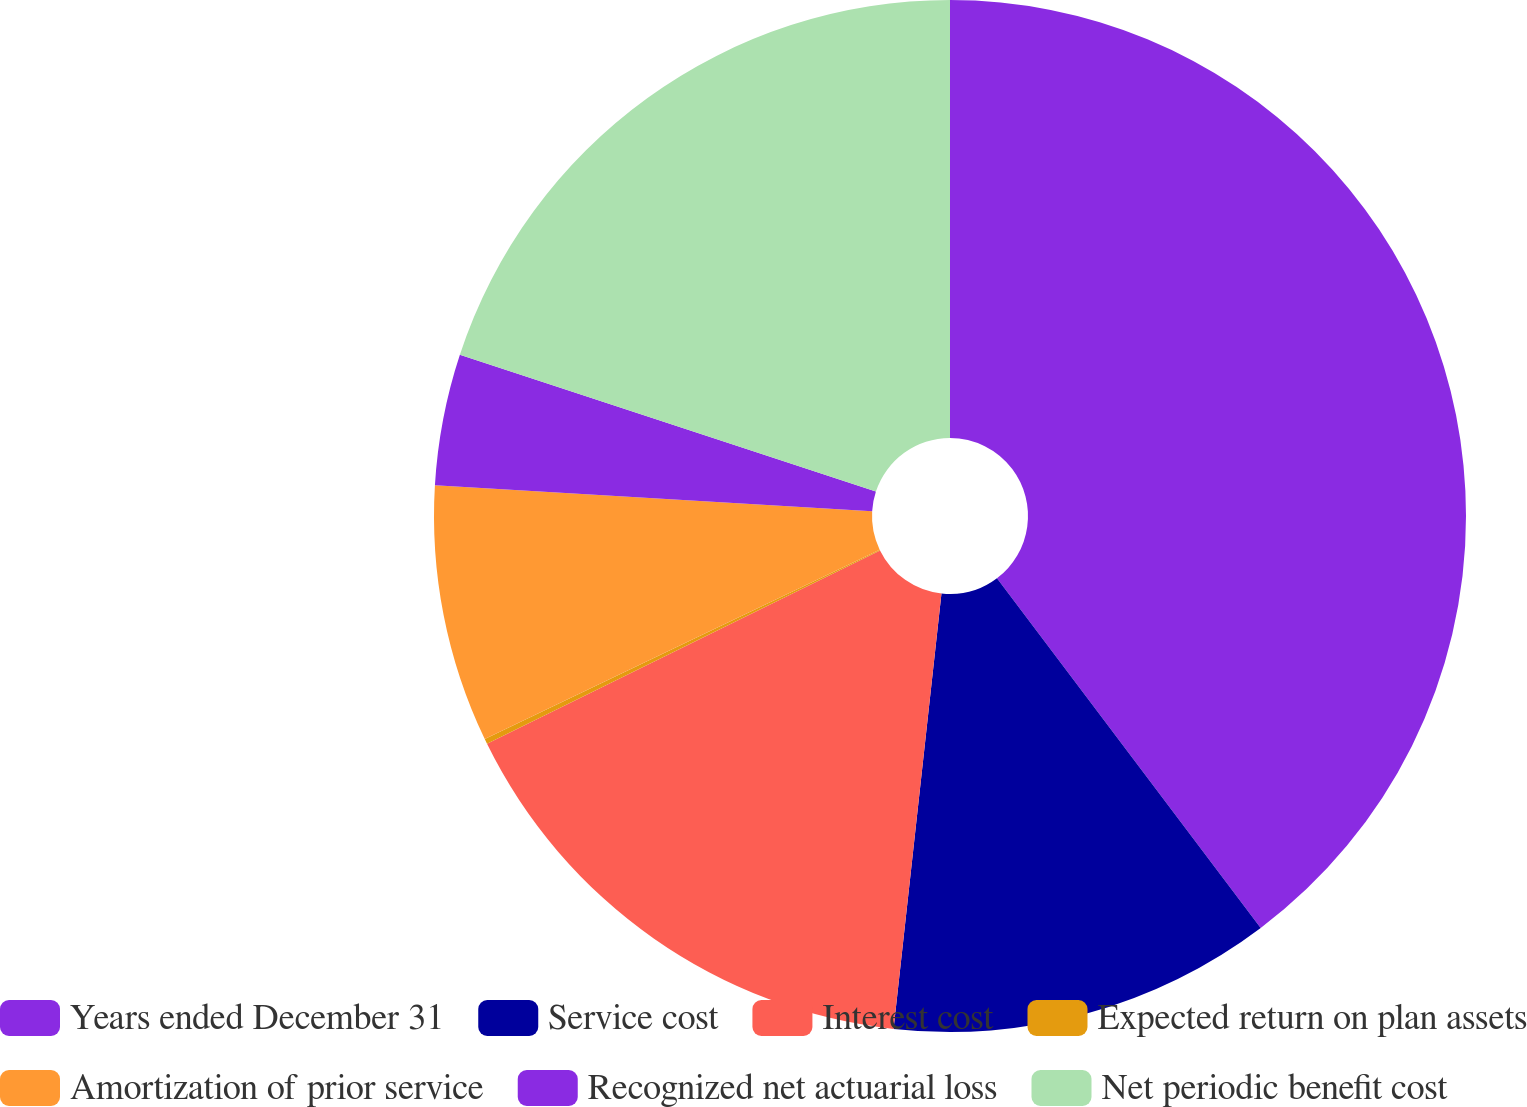<chart> <loc_0><loc_0><loc_500><loc_500><pie_chart><fcel>Years ended December 31<fcel>Service cost<fcel>Interest cost<fcel>Expected return on plan assets<fcel>Amortization of prior service<fcel>Recognized net actuarial loss<fcel>Net periodic benefit cost<nl><fcel>39.72%<fcel>12.03%<fcel>15.98%<fcel>0.16%<fcel>8.07%<fcel>4.11%<fcel>19.94%<nl></chart> 